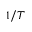<formula> <loc_0><loc_0><loc_500><loc_500>1 / T</formula> 